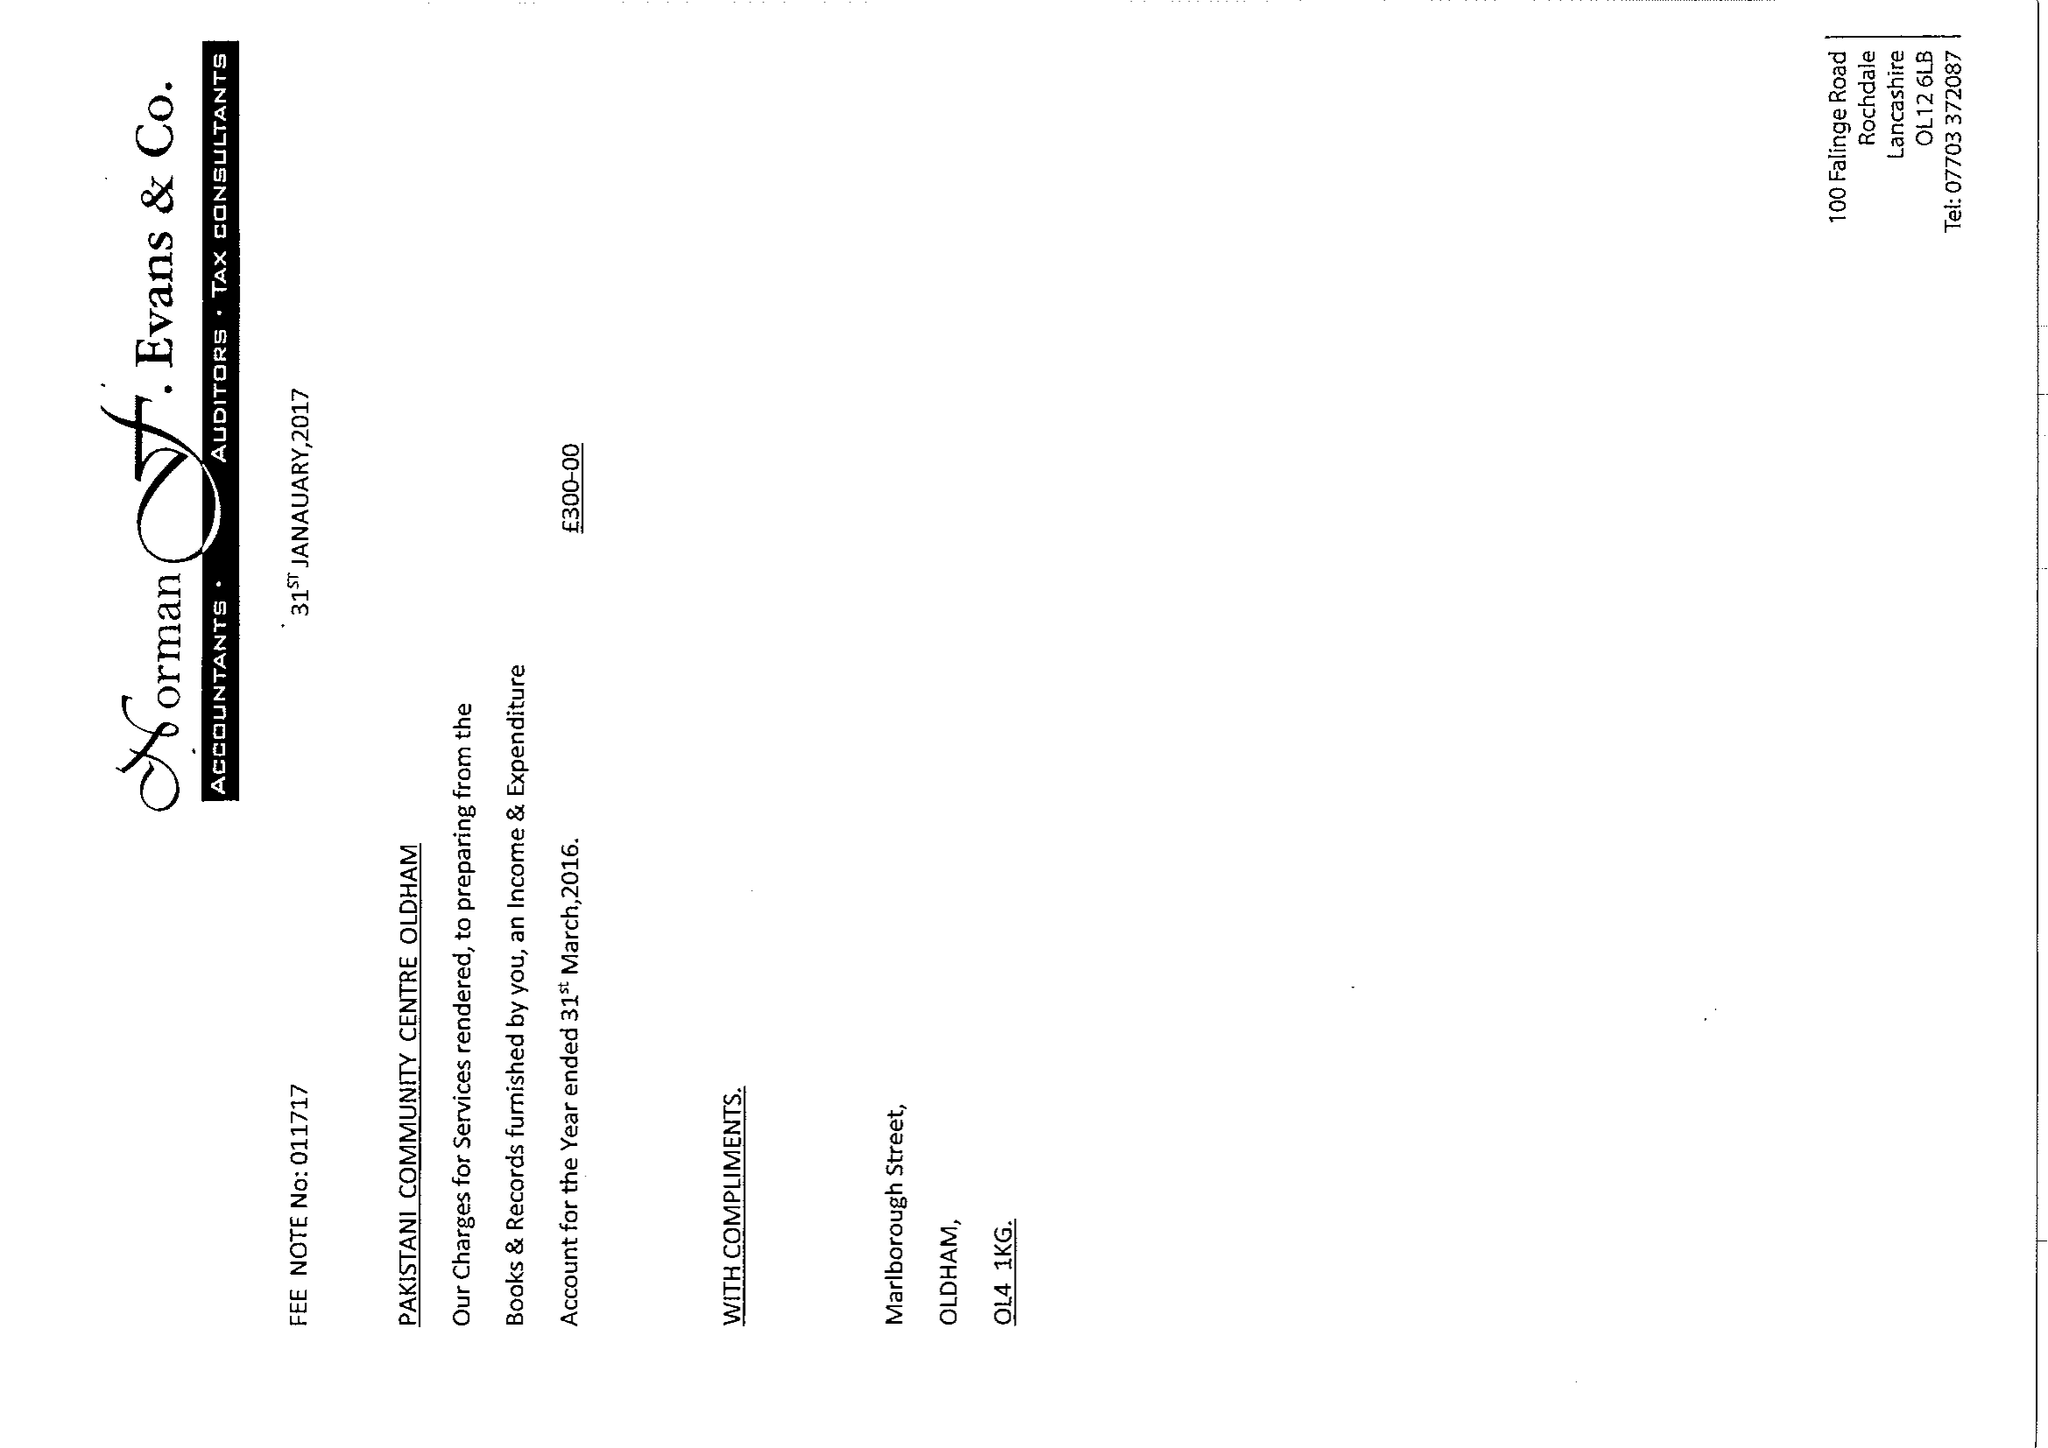What is the value for the income_annually_in_british_pounds?
Answer the question using a single word or phrase. 58590.00 